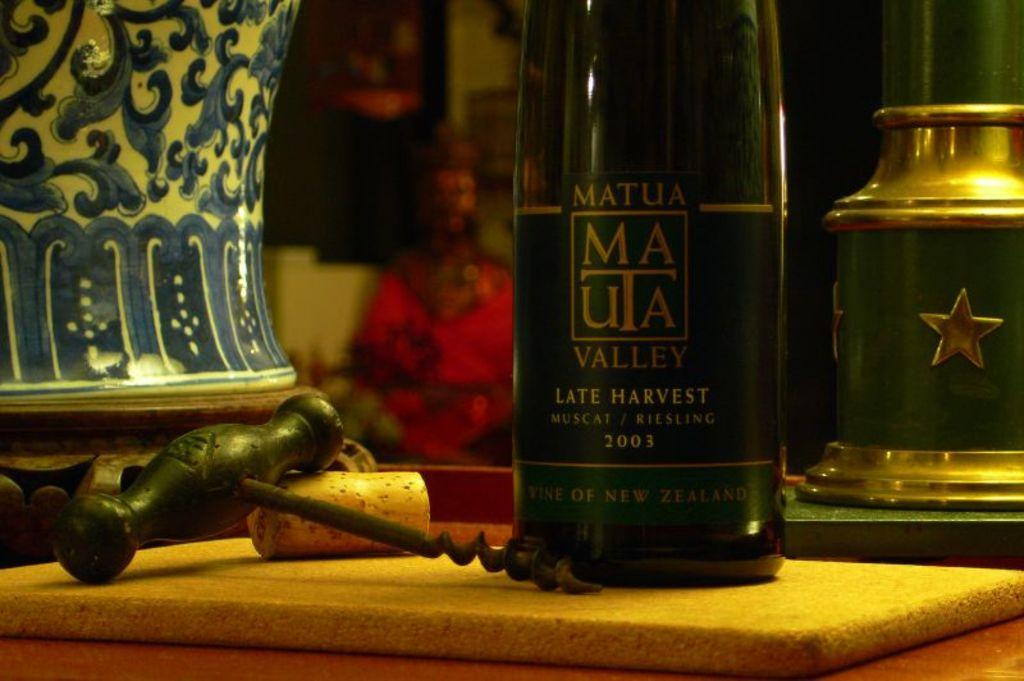<image>
Relay a brief, clear account of the picture shown. A bottle of Matua late harvest wine is on a tabletop. 